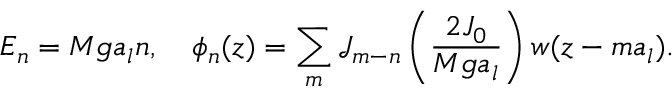<formula> <loc_0><loc_0><loc_500><loc_500>E _ { n } = M g a _ { l } n , \quad \phi _ { n } ( z ) = \sum _ { m } \mathcal { J } _ { m - n } \left ( \frac { 2 J _ { 0 } } { M g a _ { l } } \right ) w ( z - m a _ { l } ) .</formula> 